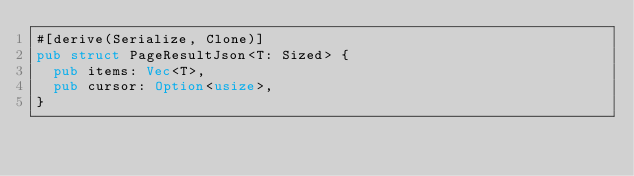<code> <loc_0><loc_0><loc_500><loc_500><_Rust_>#[derive(Serialize, Clone)]
pub struct PageResultJson<T: Sized> {
  pub items: Vec<T>,
  pub cursor: Option<usize>,
}
</code> 